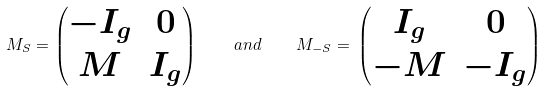<formula> <loc_0><loc_0><loc_500><loc_500>M _ { S } = \begin{pmatrix} - I _ { g } & 0 \\ M & I _ { g } \end{pmatrix} \quad a n d \quad M _ { - S } = \, \begin{pmatrix} I _ { g } & 0 \\ - M & - I _ { g } \end{pmatrix}</formula> 